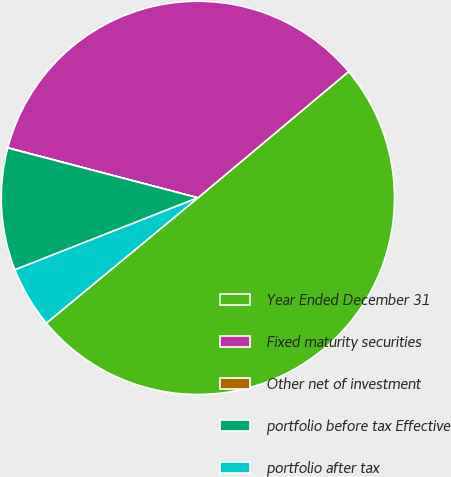<chart> <loc_0><loc_0><loc_500><loc_500><pie_chart><fcel>Year Ended December 31<fcel>Fixed maturity securities<fcel>Other net of investment<fcel>portfolio before tax Effective<fcel>portfolio after tax<nl><fcel>50.1%<fcel>34.8%<fcel>0.02%<fcel>10.04%<fcel>5.03%<nl></chart> 